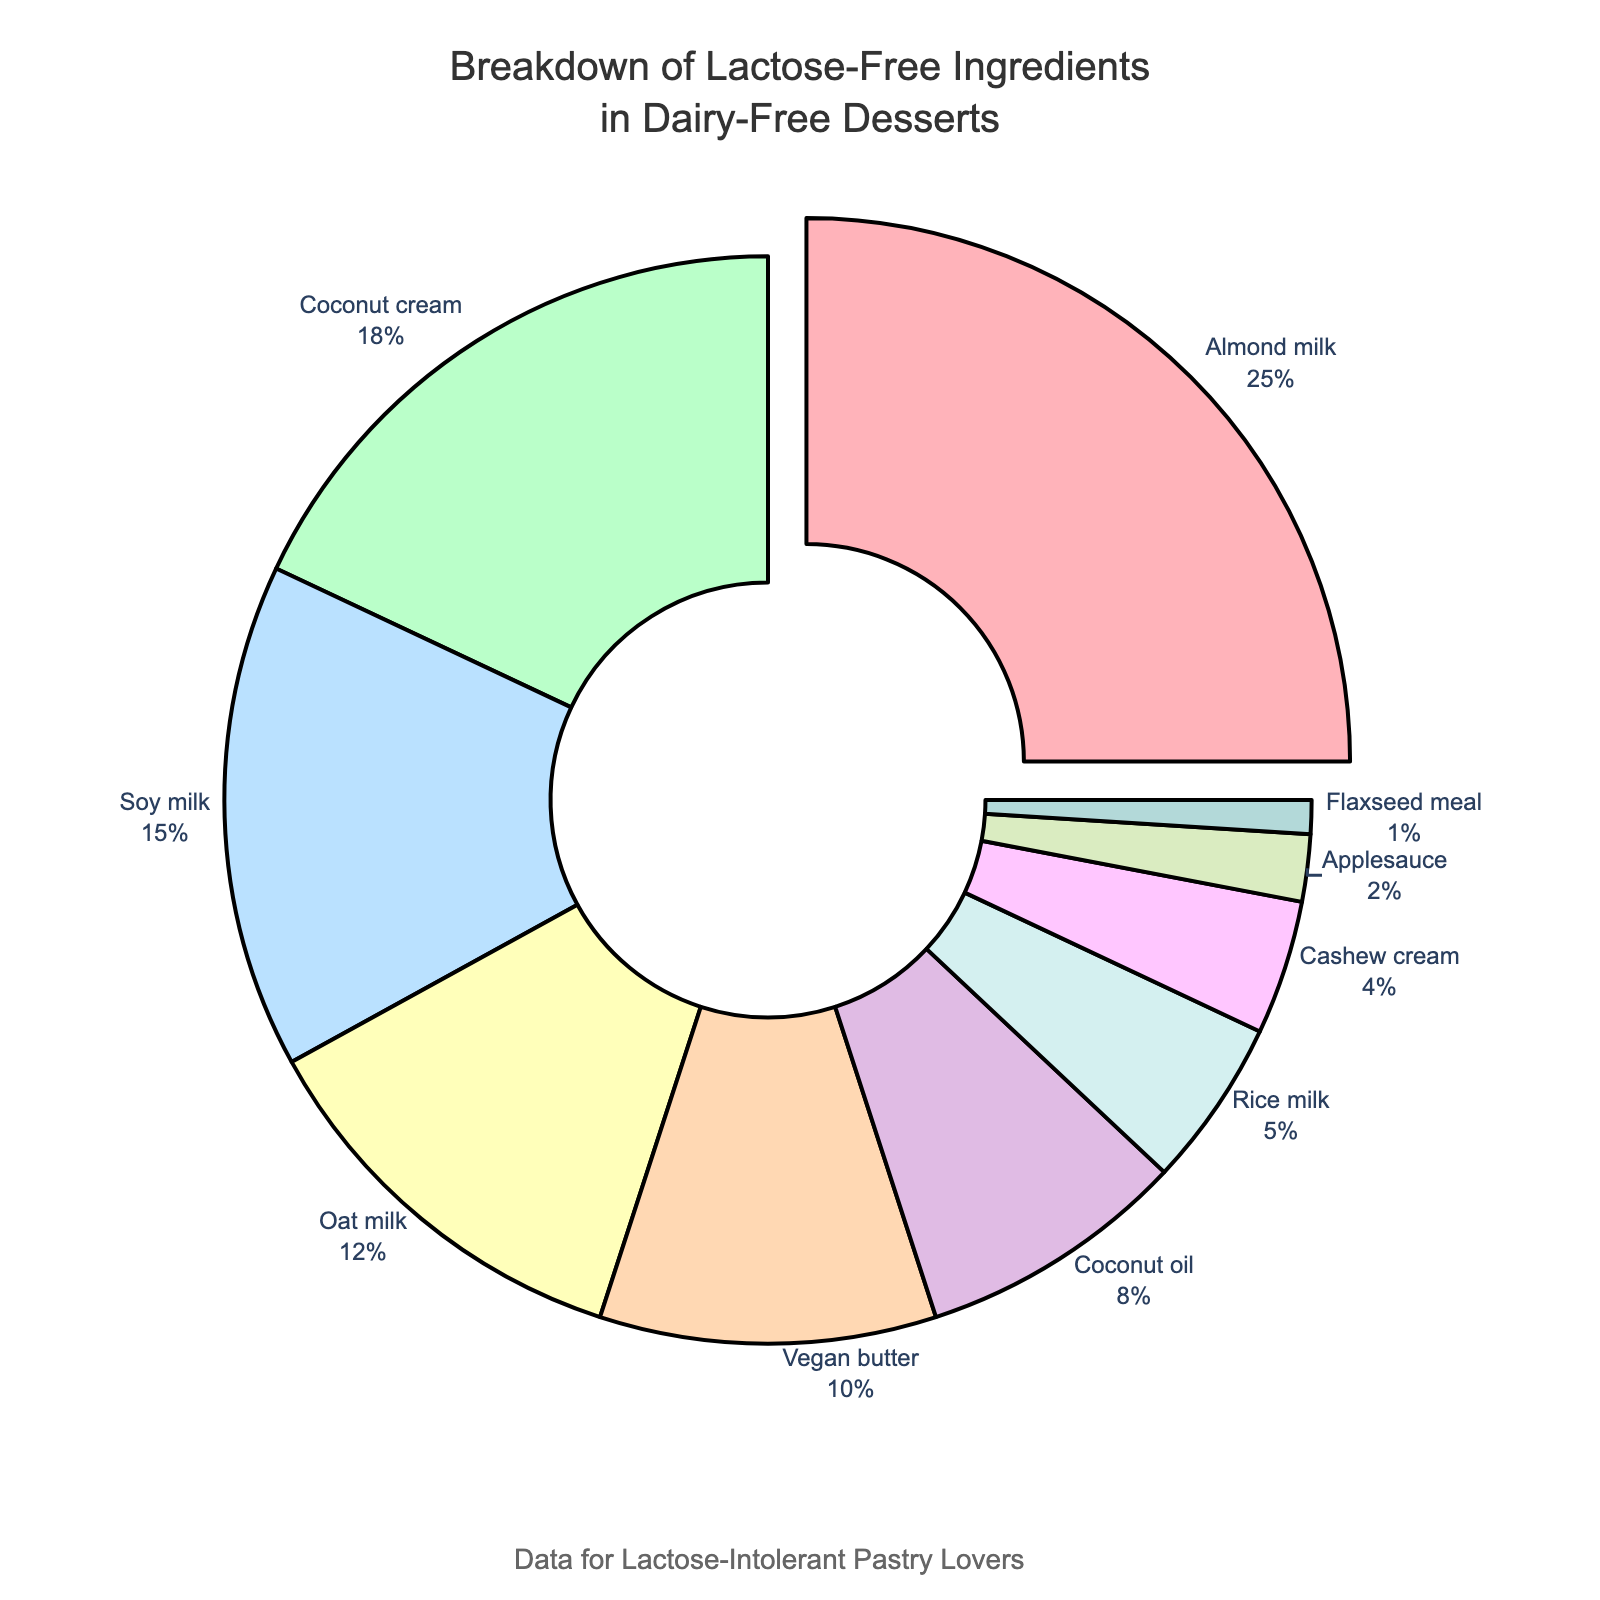what ingredient makes up the largest proportion in the pie chart? The largest segment in the pie chart, visually highlighted and pulled out slightly from the center, represents Almond milk.
Answer: Almond milk What is the total percentage of coconut-based ingredients? Add the percentages of Coconut cream (18%) and Coconut oil (8%). The total is 18% + 8% = 26%.
Answer: 26% Which ingredient has the smallest percentage and what is it? The smallest section of the pie, with the percentage label outside the pie, is Flaxseed meal at 1%.
Answer: Flaxseed meal How much larger is the percentage of Almond milk compared to Soy milk? Almond milk is 25% and Soy milk is 15%. The difference is 25% - 15% = 10%.
Answer: 10% What three ingredients make up the highest combined percentage? Identify the top three contributors: Almond milk (25%), Coconut cream (18%), and Soy milk (15%). Their combined percentage is 25% + 18% + 15% = 58%.
Answer: 58% What are the colors of the segments representing Vegan butter and Cashew cream? Vegan butter is represented by a light brown color, and Cashew cream is represented by a light pink color.
Answer: light brown, light pink Between Almond milk and Oat milk, which one has a larger proportion and by how much? Almond milk (25%) is larger than Oat milk (12%) by 25% - 12% = 13%.
Answer: Almond milk, 13% How do the percentages of Rice milk and Applesauce compare? Rice milk is 5% and Applesauce is 2%, with Rice milk having a higher percentage.
Answer: Rice milk What's the combined percentage of the ingredients that make up less than 10% each? Add the percentages of Vegan butter (10%), Coconut oil (8%), Rice milk (5%), Cashew cream (4%), Applesauce (2%), and Flaxseed meal (1%). The combined percentage is 10% + 8% + 5% + 4% + 2% + 1% = 30%.
Answer: 30% If you replace all the milk alternatives with their combined percentage, what would that total be? Sum the percentages for Almond milk (25%), Soy milk (15%), Oat milk (12%), Rice milk (5%), and Cashew cream (4%). The total is 25% + 15% + 12% + 5% + 4% = 61%.
Answer: 61% 